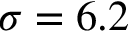Convert formula to latex. <formula><loc_0><loc_0><loc_500><loc_500>\sigma = 6 . 2</formula> 